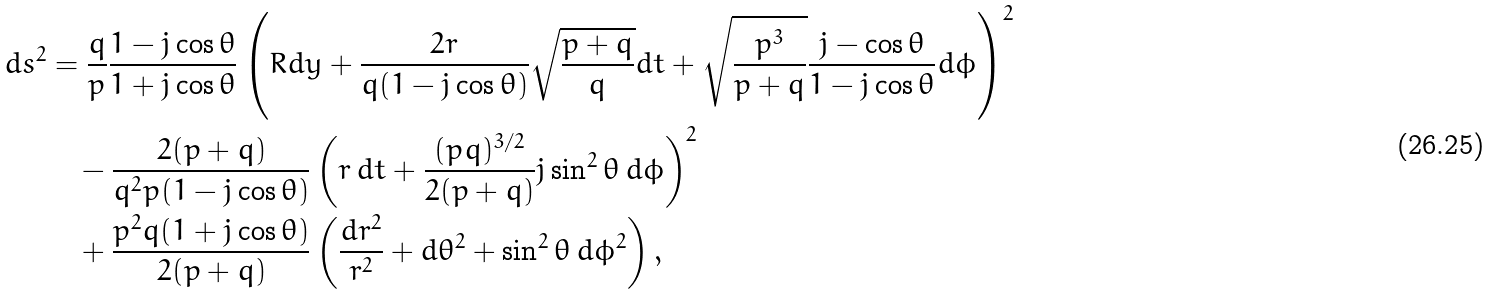<formula> <loc_0><loc_0><loc_500><loc_500>d s ^ { 2 } & = \frac { q } { p } \frac { 1 - j \cos \theta } { 1 + j \cos \theta } \left ( R d y + \frac { 2 r } { q ( 1 - j \cos \theta ) } \sqrt { \frac { p + q } { q } } d t + \sqrt { \frac { p ^ { 3 } } { p + q } } \frac { j - \cos \theta } { 1 - j \cos \theta } d \phi \right ) ^ { 2 } \\ & \quad - \frac { 2 ( p + q ) } { q ^ { 2 } p ( 1 - j \cos \theta ) } \left ( r \, d t + \frac { ( p q ) ^ { 3 / 2 } } { 2 ( p + q ) } j \sin ^ { 2 } \theta \, d \phi \right ) ^ { 2 } \\ & \quad + \frac { p ^ { 2 } q ( 1 + j \cos \theta ) } { 2 ( p + q ) } \left ( \frac { d r ^ { 2 } } { r ^ { 2 } } + d \theta ^ { 2 } + \sin ^ { 2 } \theta \, d \phi ^ { 2 } \right ) ,</formula> 